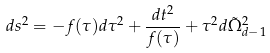Convert formula to latex. <formula><loc_0><loc_0><loc_500><loc_500>d s ^ { 2 } = - f ( \tau ) d \tau ^ { 2 } + \frac { d t ^ { 2 } } { f ( \tau ) } + \tau ^ { 2 } d \tilde { \Omega } _ { d - 1 } ^ { 2 }</formula> 